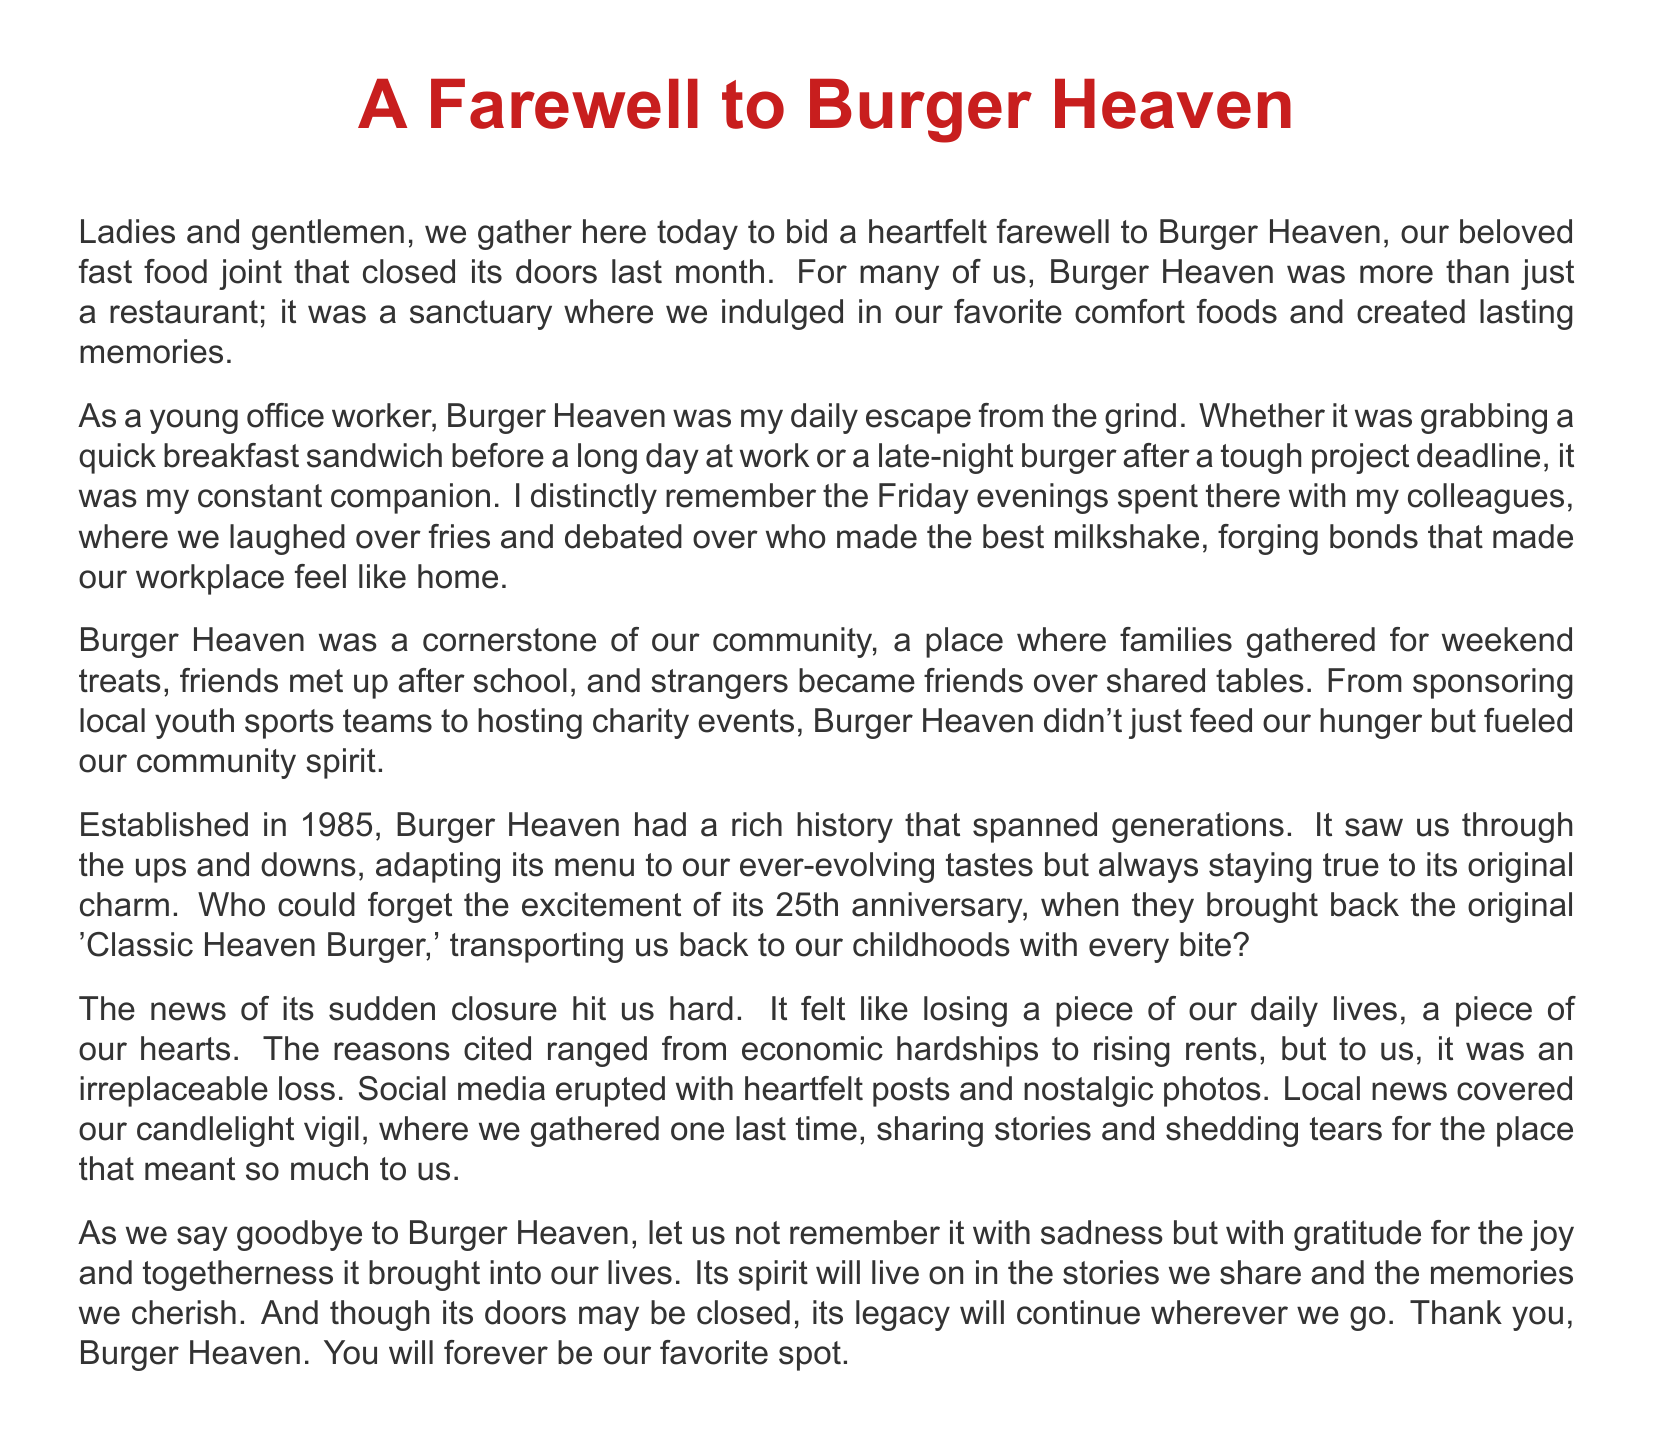What was the name of the fast food joint? The document refers to the fast food restaurant as Burger Heaven.
Answer: Burger Heaven In what year was Burger Heaven established? The document states that Burger Heaven was established in 1985.
Answer: 1985 What was the original burger mentioned in the 25th anniversary? The document mentions the 'Classic Heaven Burger' as the original burger brought back.
Answer: Classic Heaven Burger What type of events did Burger Heaven host? The document mentions that Burger Heaven hosted charity events as part of its community engagement.
Answer: Charity events What feelings did the closure of Burger Heaven evoke in the community? The document describes the feelings as sadness and loss due to its sudden closure.
Answer: Sadness and loss How long did Burger Heaven operate? The document indicates that Burger Heaven had a rich history that spanned generations, implying it operated for many years since 1985.
Answer: Generations What activity did people engage in at the candlelight vigil? The document mentions that attendees shared stories during the candlelight vigil.
Answer: Sharing stories What was the primary reason for the closure of Burger Heaven? The document cites economic hardships and rising rents as reasons for the closure.
Answer: Economic hardships and rising rents What overall sentiment does the eulogy express towards Burger Heaven? The eulogy expresses gratitude for the joy and togetherness that Burger Heaven brought into lives.
Answer: Gratitude 